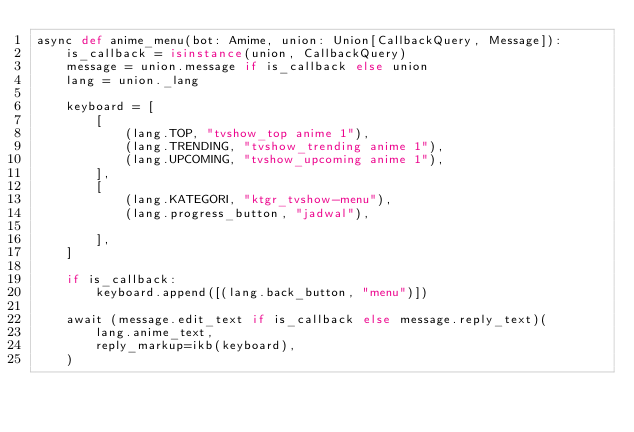<code> <loc_0><loc_0><loc_500><loc_500><_Python_>async def anime_menu(bot: Amime, union: Union[CallbackQuery, Message]):
    is_callback = isinstance(union, CallbackQuery)
    message = union.message if is_callback else union
    lang = union._lang

    keyboard = [
        [
            (lang.TOP, "tvshow_top anime 1"),
            (lang.TRENDING, "tvshow_trending anime 1"),
            (lang.UPCOMING, "tvshow_upcoming anime 1"),
        ],
        [
            (lang.KATEGORI, "ktgr_tvshow-menu"),
            (lang.progress_button, "jadwal"),
            
        ],
    ]

    if is_callback:
        keyboard.append([(lang.back_button, "menu")])

    await (message.edit_text if is_callback else message.reply_text)(
        lang.anime_text,
        reply_markup=ikb(keyboard),
    )</code> 